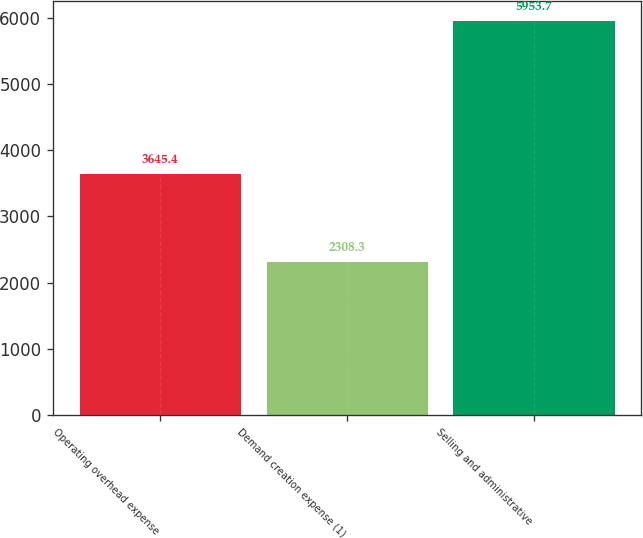<chart> <loc_0><loc_0><loc_500><loc_500><bar_chart><fcel>Operating overhead expense<fcel>Demand creation expense (1)<fcel>Selling and administrative<nl><fcel>3645.4<fcel>2308.3<fcel>5953.7<nl></chart> 